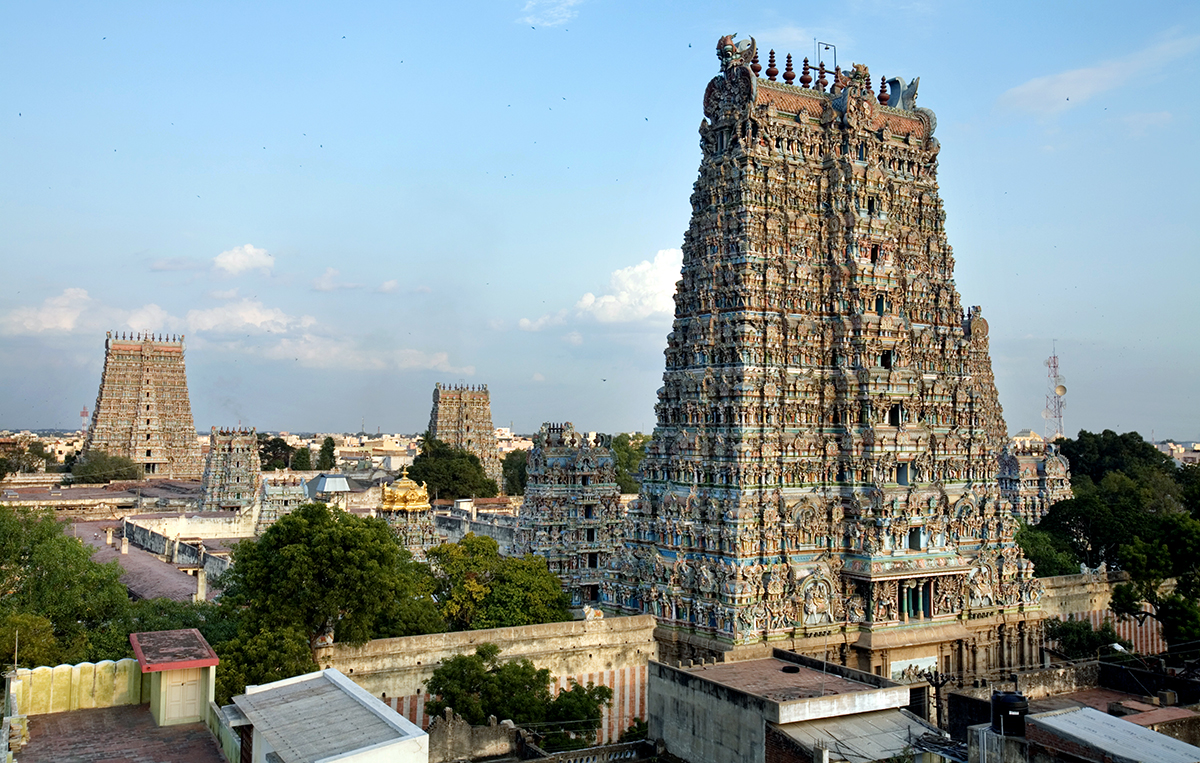Can you elaborate on the elements of the picture provided? The photograph captures the striking Meenakshi Amman Temple in Madurai, India, renowned for its historical significance and architectural brilliance. The temple's towering gopurams, decorated with thousands of colorful statues and stone carvings, depict various deities and mythological scenes, showcasing the artistic traditions of the Tamil people. This view also illustrates how the temple, a pivotal element of Madurai's heritage, contrasts yet integrates beautifully with the surrounding urban fabric, which mixes old and contemporary structures. A deeper look even reveals birds in flight, adding a dynamic element to the serene and sacred atmosphere of the temple premises. 